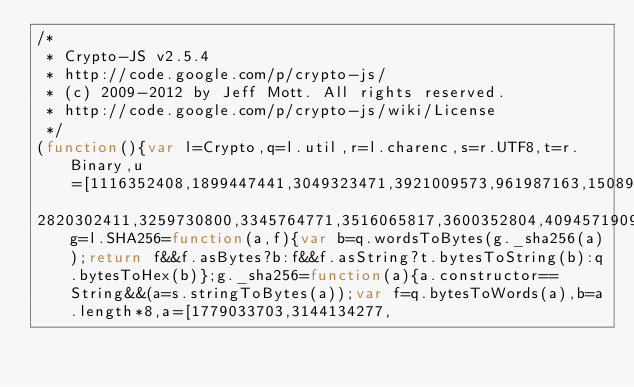<code> <loc_0><loc_0><loc_500><loc_500><_JavaScript_>/*
 * Crypto-JS v2.5.4
 * http://code.google.com/p/crypto-js/
 * (c) 2009-2012 by Jeff Mott. All rights reserved.
 * http://code.google.com/p/crypto-js/wiki/License
 */
(function(){var l=Crypto,q=l.util,r=l.charenc,s=r.UTF8,t=r.Binary,u=[1116352408,1899447441,3049323471,3921009573,961987163,1508970993,2453635748,2870763221,3624381080,310598401,607225278,1426881987,1925078388,2162078206,2614888103,3248222580,3835390401,4022224774,264347078,604807628,770255983,1249150122,1555081692,1996064986,2554220882,2821834349,2952996808,3210313671,3336571891,3584528711,113926993,338241895,666307205,773529912,1294757372,1396182291,1695183700,1986661051,2177026350,2456956037,2730485921,
2820302411,3259730800,3345764771,3516065817,3600352804,4094571909,275423344,430227734,506948616,659060556,883997877,958139571,1322822218,1537002063,1747873779,1955562222,2024104815,2227730452,2361852424,2428436474,2756734187,3204031479,3329325298],g=l.SHA256=function(a,f){var b=q.wordsToBytes(g._sha256(a));return f&&f.asBytes?b:f&&f.asString?t.bytesToString(b):q.bytesToHex(b)};g._sha256=function(a){a.constructor==String&&(a=s.stringToBytes(a));var f=q.bytesToWords(a),b=a.length*8,a=[1779033703,3144134277,</code> 